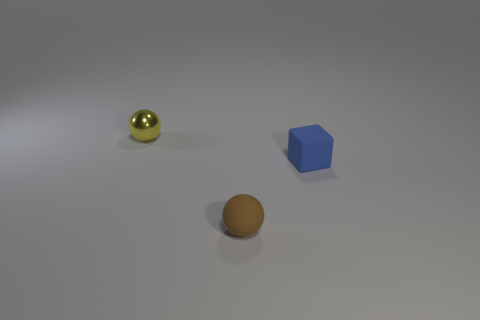Are the blue cube and the small sphere behind the blue matte block made of the same material?
Ensure brevity in your answer.  No. What is the material of the yellow sphere?
Provide a short and direct response. Metal. What number of other objects are there of the same material as the tiny brown thing?
Your answer should be compact. 1. There is a tiny thing that is both behind the rubber ball and in front of the metal thing; what shape is it?
Make the answer very short. Cube. The other thing that is the same material as the tiny brown thing is what color?
Provide a short and direct response. Blue. Are there an equal number of tiny yellow objects in front of the blue rubber block and metallic objects?
Keep it short and to the point. No. The yellow thing that is the same size as the brown thing is what shape?
Your response must be concise. Sphere. How many other objects are the same shape as the brown thing?
Offer a very short reply. 1. There is a yellow shiny object; does it have the same size as the sphere that is right of the tiny yellow metallic sphere?
Keep it short and to the point. Yes. How many objects are balls to the right of the tiny metal ball or tiny spheres?
Ensure brevity in your answer.  2. 